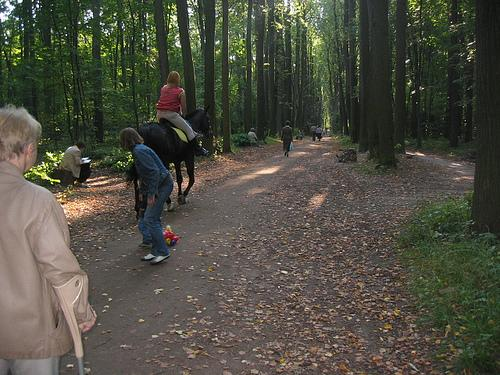Select a detail related to the clothing of a woman on a horse in the image. The woman riding the horse is wearing a red top. Mention two elements found on the ground in the image. Leaves scattered on the path and sunlight on the pathway. What is the condition of the trees and leaves in the image? There are green tree leaves, dry leaves on the ground, and a tall tree branch. Please give a brief description of a scene involving a woman and a log in the image. A woman is sitting on a log in the woods with a crutch nearby. Identify the color and type of animal being ridden by the woman in the image. The woman is riding a black horse. What is the activity of the person in the red shirt in the image? The person in the red shirt is riding a horse. Describe what a person wearing a blue jacket can be seen doing in the image. A person wearing a blue jacket is standing behind a horse. Describe the environment where the people in the image are located. The people are in the woods with sunlight coming through the trees. 